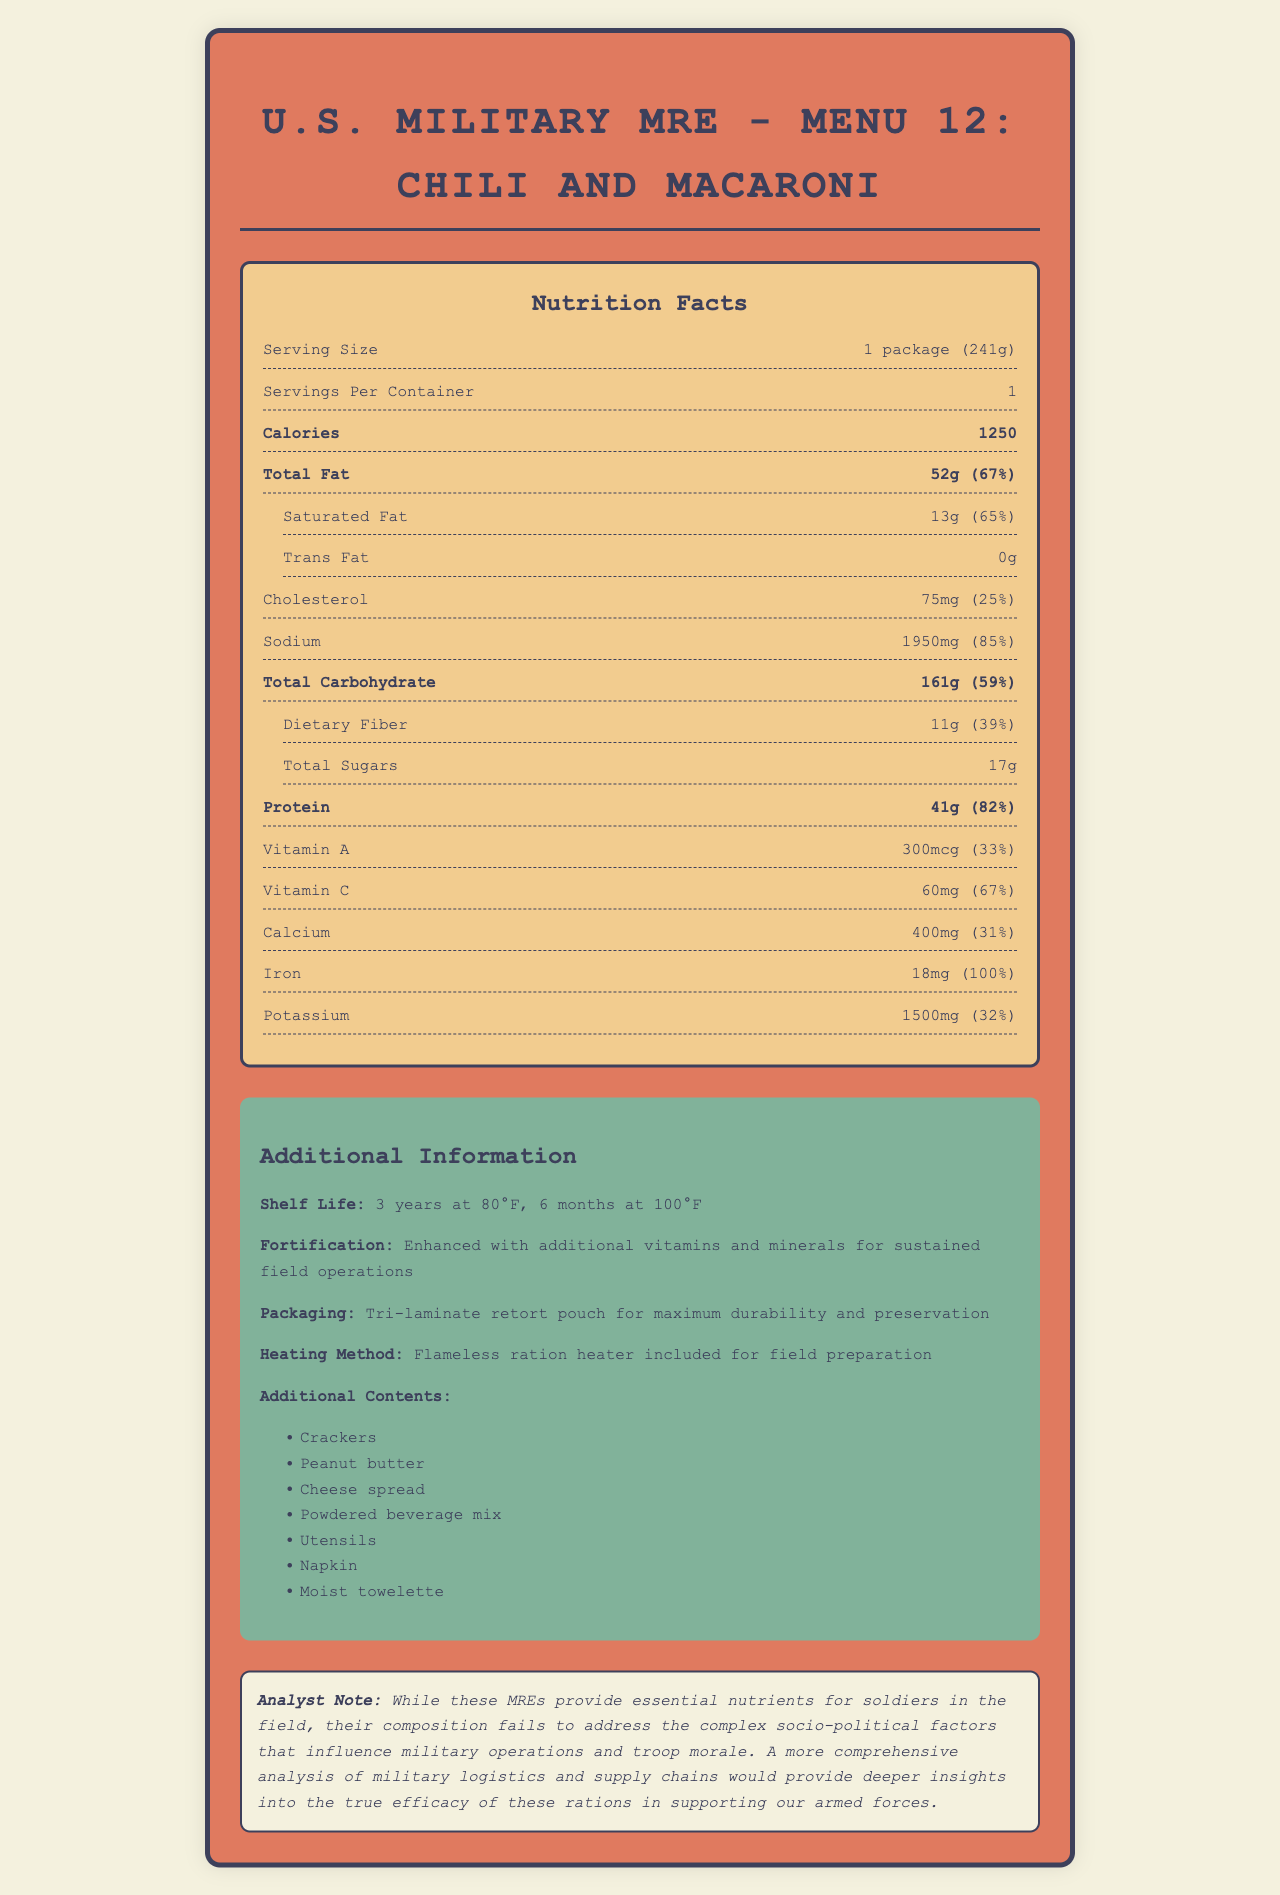what is the serving size? The serving size is listed as 1 package (241g) in the nutrition facts section.
Answer: 1 package (241g) how many calories are in one serving of this MRE? The calories per serving are mentioned under the bolded "Calories" section.
Answer: 1250 what is the daily value percentage of sodium? The daily value percentage of sodium is given as 85%, next to the sodium amount.
Answer: 85% how long is the shelf life at 80°F? The shelf life is specified as "3 years at 80°F" in the additional information section.
Answer: 3 years which vitamin has the highest daily value percentage? The daily value percentage for iron is 100%, which is the highest among all listed vitamins and minerals.
Answer: Iron which macronutrient is provided in the highest amount? A. Protein B. Carbohydrate C. Fat The total carbohydrate amount is 161g, which is higher than both protein (41g) and total fat (52g).
Answer: B what fortification does this MRE have? A. Added Fiber B. Additional vitamins and minerals C. Extra Protein D. Reduced Sodium The document states "Enhanced with additional vitamins and minerals for sustained field operations" under fortification.
Answer: B is the trans fat content of the MRE significant? The trans fat content is listed as 0g, indicating it is not significant.
Answer: No does the document provide any information on how to heat the MRE? The document mentions a "Flameless ration heater included for field preparation" under the heating method.
Answer: Yes what is the main idea of the document? The document summarizes various aspects like nutrition content, additional features, and durability information, all aimed at ensuring the effectiveness of the MRE for soldiers in field conditions.
Answer: The document provides detailed nutrition facts, shelf life, fortification, packaging, and additional contents of the U.S. Military MRE - Menu 12: Chili and Macaroni, highlighting its nutrient density and durability for field operations. what are the socio-political factors that influence military operations and troop morale? The document includes a note stating the importance of more comprehensive analysis but does not detail specific socio-political factors influencing military operations and troop morale.
Answer: Cannot be determined 